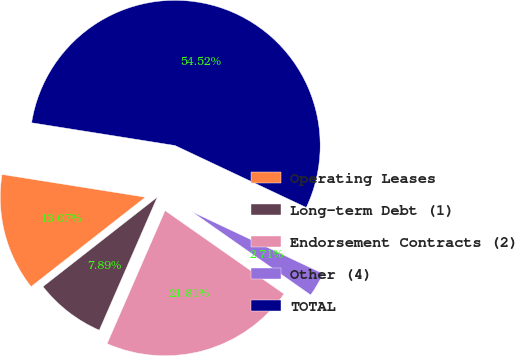Convert chart. <chart><loc_0><loc_0><loc_500><loc_500><pie_chart><fcel>Operating Leases<fcel>Long-term Debt (1)<fcel>Endorsement Contracts (2)<fcel>Other (4)<fcel>TOTAL<nl><fcel>13.07%<fcel>7.89%<fcel>21.81%<fcel>2.71%<fcel>54.51%<nl></chart> 